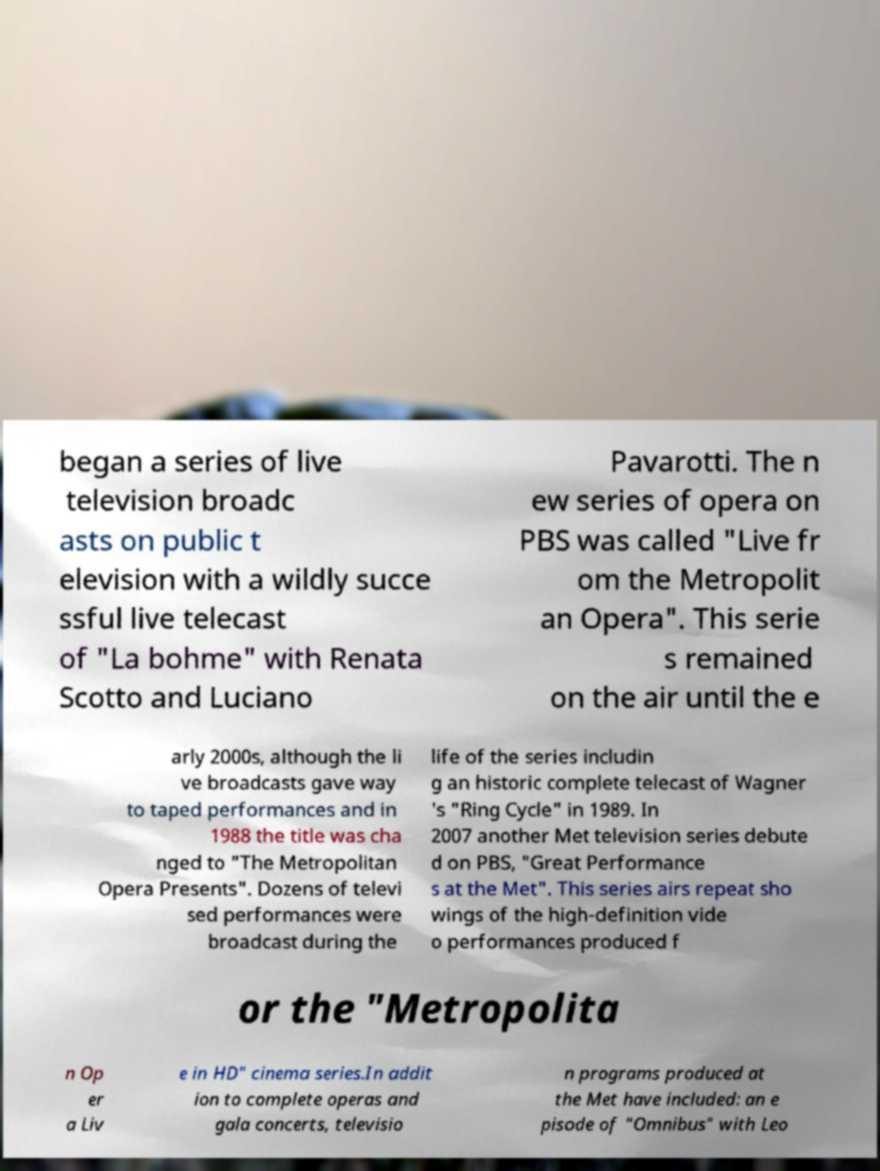What messages or text are displayed in this image? I need them in a readable, typed format. began a series of live television broadc asts on public t elevision with a wildly succe ssful live telecast of "La bohme" with Renata Scotto and Luciano Pavarotti. The n ew series of opera on PBS was called "Live fr om the Metropolit an Opera". This serie s remained on the air until the e arly 2000s, although the li ve broadcasts gave way to taped performances and in 1988 the title was cha nged to "The Metropolitan Opera Presents". Dozens of televi sed performances were broadcast during the life of the series includin g an historic complete telecast of Wagner 's "Ring Cycle" in 1989. In 2007 another Met television series debute d on PBS, "Great Performance s at the Met". This series airs repeat sho wings of the high-definition vide o performances produced f or the "Metropolita n Op er a Liv e in HD" cinema series.In addit ion to complete operas and gala concerts, televisio n programs produced at the Met have included: an e pisode of "Omnibus" with Leo 